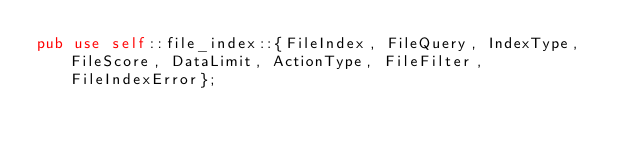<code> <loc_0><loc_0><loc_500><loc_500><_Rust_>pub use self::file_index::{FileIndex, FileQuery, IndexType, FileScore, DataLimit, ActionType, FileFilter, FileIndexError};
</code> 